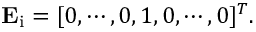Convert formula to latex. <formula><loc_0><loc_0><loc_500><loc_500>E _ { i } = [ 0 , \cdots , 0 , 1 , 0 , \cdots , 0 ] ^ { T } .</formula> 